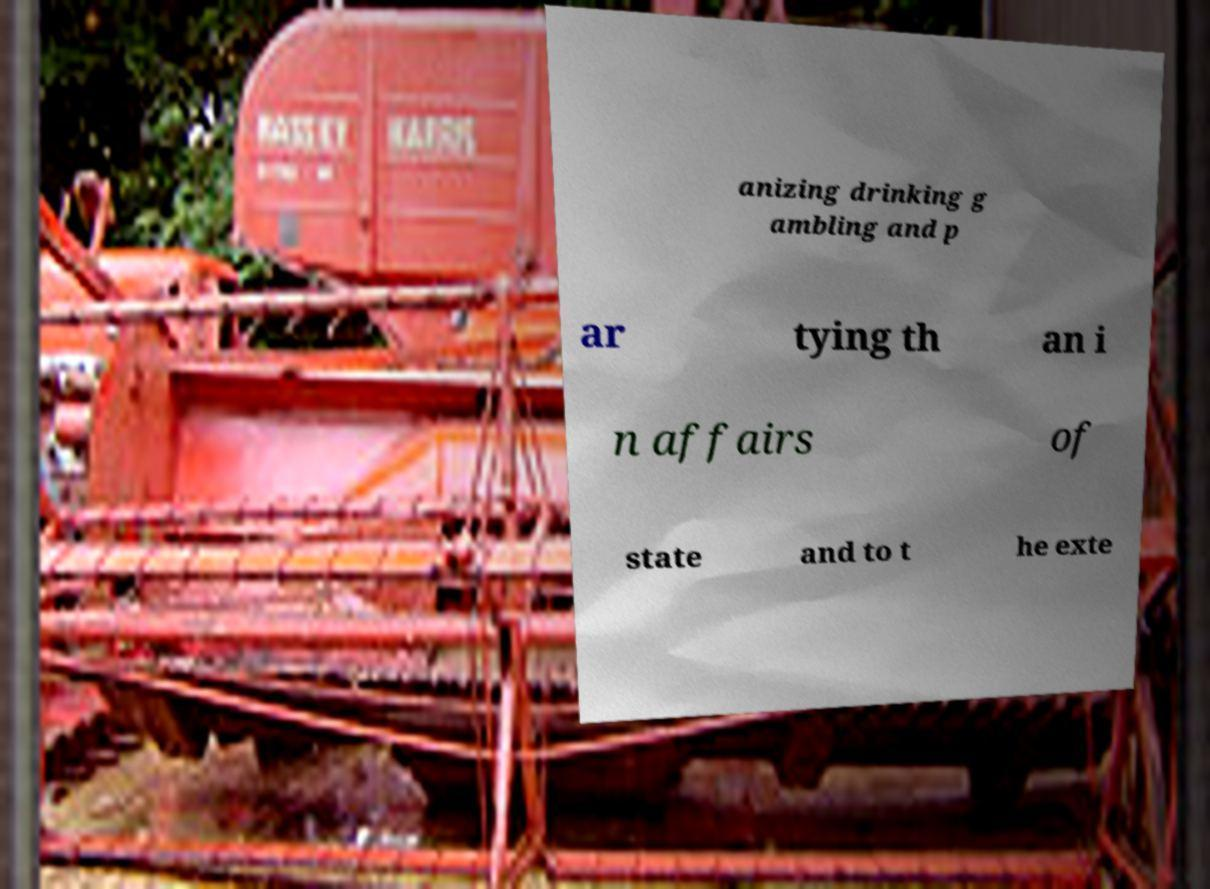Could you assist in decoding the text presented in this image and type it out clearly? anizing drinking g ambling and p ar tying th an i n affairs of state and to t he exte 